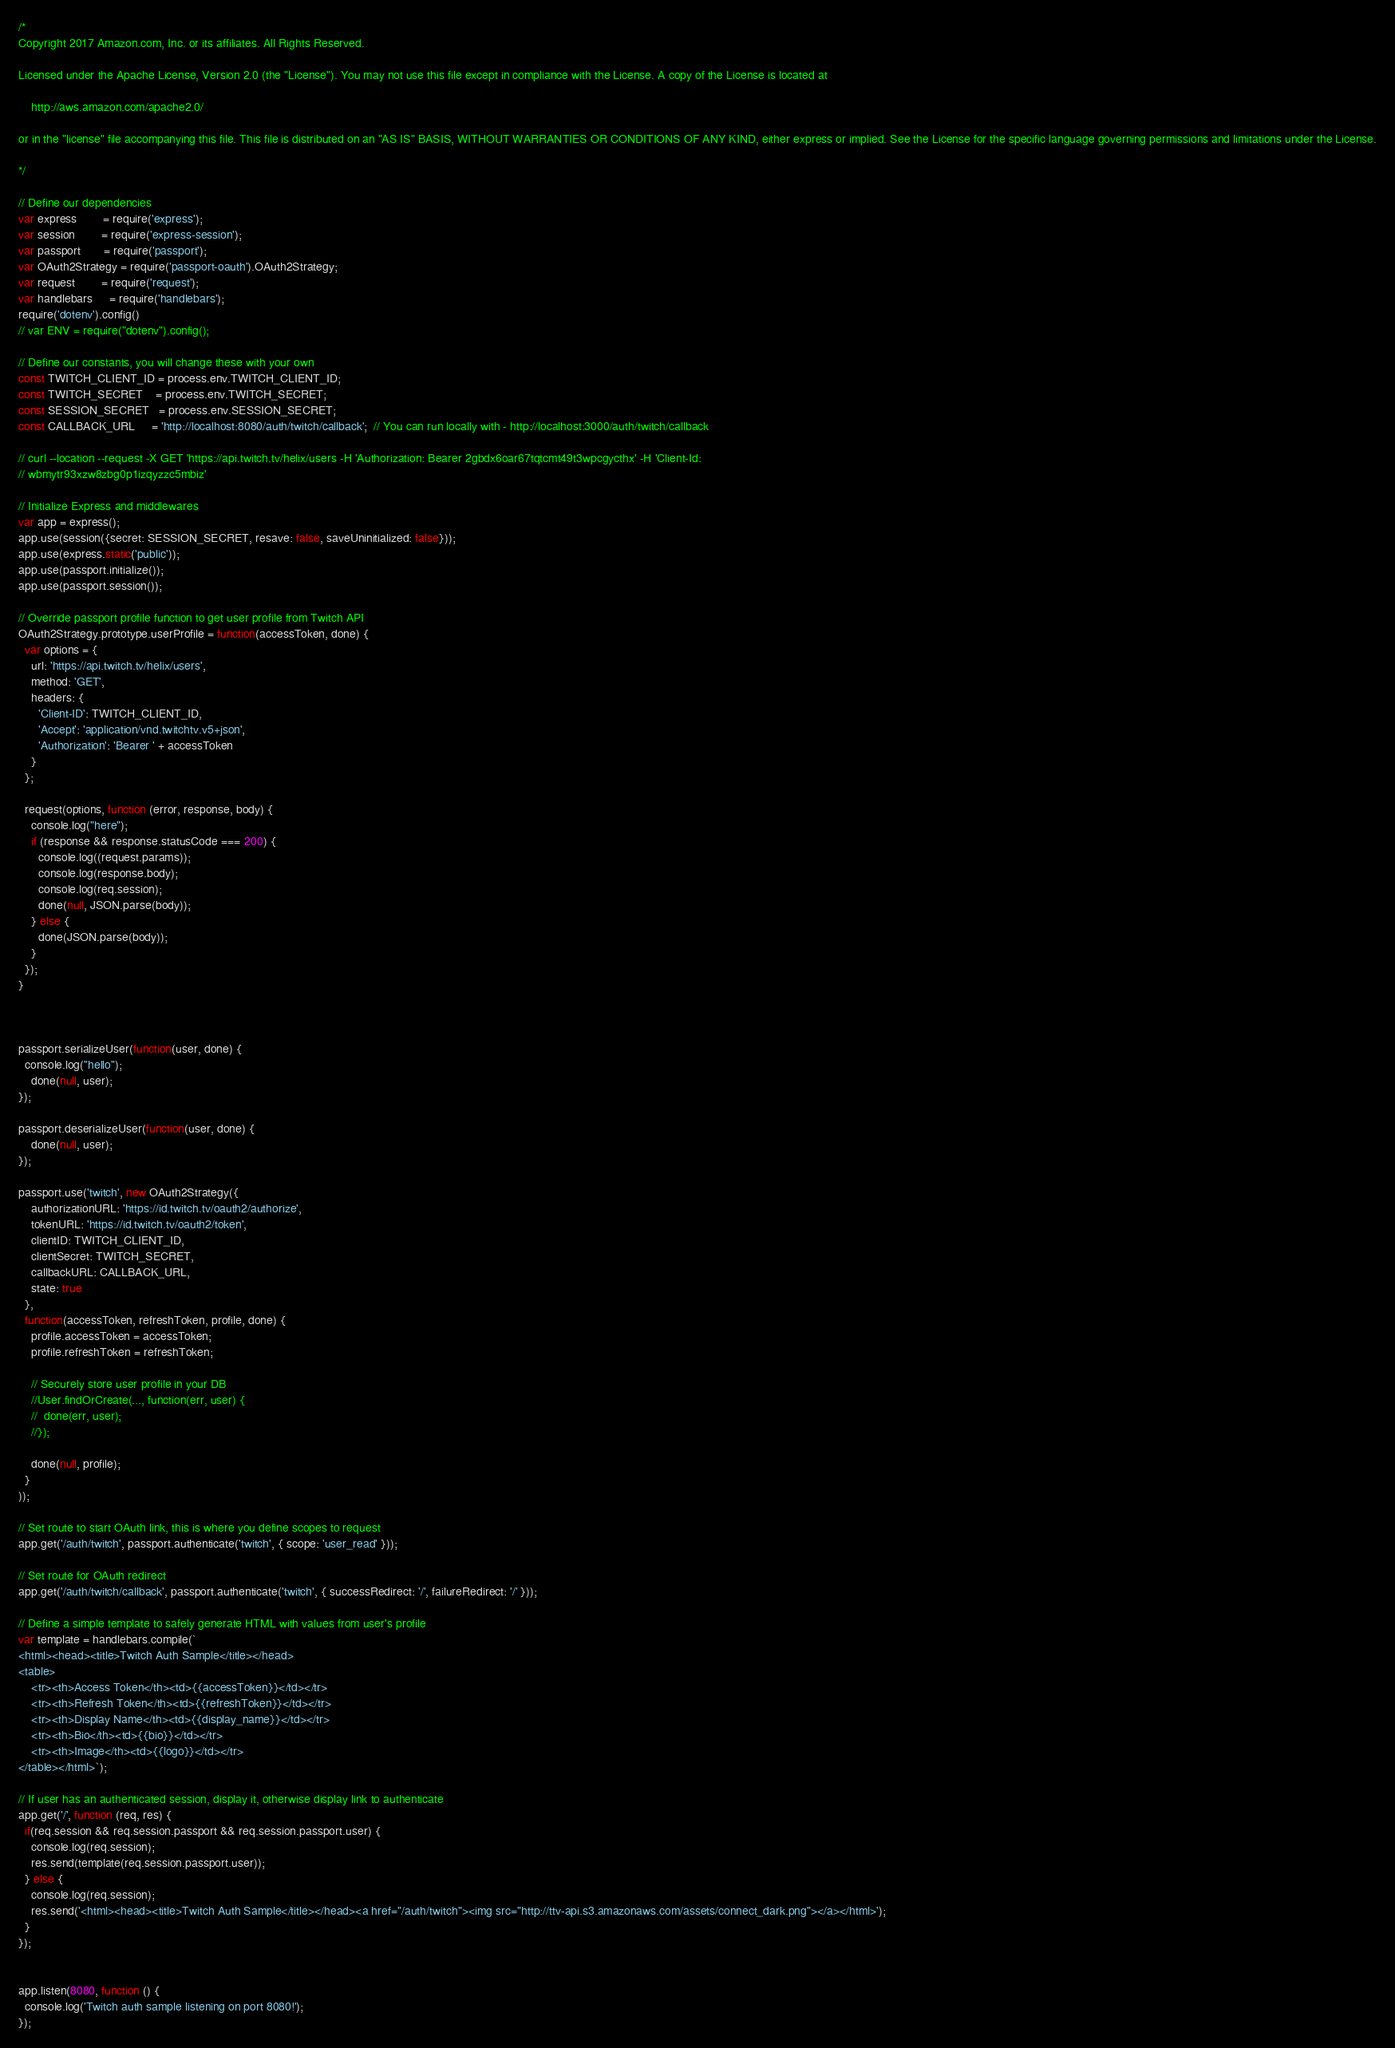<code> <loc_0><loc_0><loc_500><loc_500><_JavaScript_>/*
Copyright 2017 Amazon.com, Inc. or its affiliates. All Rights Reserved.

Licensed under the Apache License, Version 2.0 (the "License"). You may not use this file except in compliance with the License. A copy of the License is located at

    http://aws.amazon.com/apache2.0/

or in the "license" file accompanying this file. This file is distributed on an "AS IS" BASIS, WITHOUT WARRANTIES OR CONDITIONS OF ANY KIND, either express or implied. See the License for the specific language governing permissions and limitations under the License.

*/

// Define our dependencies
var express        = require('express');
var session        = require('express-session');
var passport       = require('passport');
var OAuth2Strategy = require('passport-oauth').OAuth2Strategy;
var request        = require('request');
var handlebars     = require('handlebars');
require('dotenv').config()
// var ENV = require("dotenv").config();

// Define our constants, you will change these with your own
const TWITCH_CLIENT_ID = process.env.TWITCH_CLIENT_ID;
const TWITCH_SECRET    = process.env.TWITCH_SECRET;
const SESSION_SECRET   = process.env.SESSION_SECRET;
const CALLBACK_URL     = 'http://localhost:8080/auth/twitch/callback';  // You can run locally with - http://localhost:3000/auth/twitch/callback

// curl --location --request -X GET 'https://api.twitch.tv/helix/users -H 'Authorization: Bearer 2gbdx6oar67tqtcmt49t3wpcgycthx' -H 'Client-Id:
// wbmytr93xzw8zbg0p1izqyzzc5mbiz'

// Initialize Express and middlewares
var app = express();
app.use(session({secret: SESSION_SECRET, resave: false, saveUninitialized: false}));
app.use(express.static('public'));
app.use(passport.initialize());
app.use(passport.session());

// Override passport profile function to get user profile from Twitch API
OAuth2Strategy.prototype.userProfile = function(accessToken, done) {
  var options = {
    url: 'https://api.twitch.tv/helix/users',
    method: 'GET',
    headers: {
      'Client-ID': TWITCH_CLIENT_ID,
      'Accept': 'application/vnd.twitchtv.v5+json',
      'Authorization': 'Bearer ' + accessToken
    }
  };

  request(options, function (error, response, body) {
    console.log("here");
    if (response && response.statusCode === 200) {
      console.log((request.params));
      console.log(response.body);
      console.log(req.session);
      done(null, JSON.parse(body));
    } else {
      done(JSON.parse(body));
    }
  });
}



passport.serializeUser(function(user, done) {
  console.log("hello");
    done(null, user);
});

passport.deserializeUser(function(user, done) {
    done(null, user);
});

passport.use('twitch', new OAuth2Strategy({
    authorizationURL: 'https://id.twitch.tv/oauth2/authorize',
    tokenURL: 'https://id.twitch.tv/oauth2/token',
    clientID: TWITCH_CLIENT_ID,
    clientSecret: TWITCH_SECRET,
    callbackURL: CALLBACK_URL,
    state: true
  },
  function(accessToken, refreshToken, profile, done) {
    profile.accessToken = accessToken;
    profile.refreshToken = refreshToken;

    // Securely store user profile in your DB
    //User.findOrCreate(..., function(err, user) {
    //  done(err, user);
    //});

    done(null, profile);
  }
));

// Set route to start OAuth link, this is where you define scopes to request
app.get('/auth/twitch', passport.authenticate('twitch', { scope: 'user_read' }));

// Set route for OAuth redirect
app.get('/auth/twitch/callback', passport.authenticate('twitch', { successRedirect: '/', failureRedirect: '/' }));

// Define a simple template to safely generate HTML with values from user's profile
var template = handlebars.compile(`
<html><head><title>Twitch Auth Sample</title></head>
<table>
    <tr><th>Access Token</th><td>{{accessToken}}</td></tr>
    <tr><th>Refresh Token</th><td>{{refreshToken}}</td></tr>
    <tr><th>Display Name</th><td>{{display_name}}</td></tr>
    <tr><th>Bio</th><td>{{bio}}</td></tr>
    <tr><th>Image</th><td>{{logo}}</td></tr>
</table></html>`);

// If user has an authenticated session, display it, otherwise display link to authenticate
app.get('/', function (req, res) {
  if(req.session && req.session.passport && req.session.passport.user) {
    console.log(req.session);
    res.send(template(req.session.passport.user));
  } else {
    console.log(req.session);
    res.send('<html><head><title>Twitch Auth Sample</title></head><a href="/auth/twitch"><img src="http://ttv-api.s3.amazonaws.com/assets/connect_dark.png"></a></html>');
  }
});


app.listen(8080, function () {
  console.log('Twitch auth sample listening on port 8080!');
});
</code> 